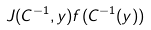Convert formula to latex. <formula><loc_0><loc_0><loc_500><loc_500>J ( C ^ { - 1 } , y ) f ( C ^ { - 1 } ( y ) )</formula> 